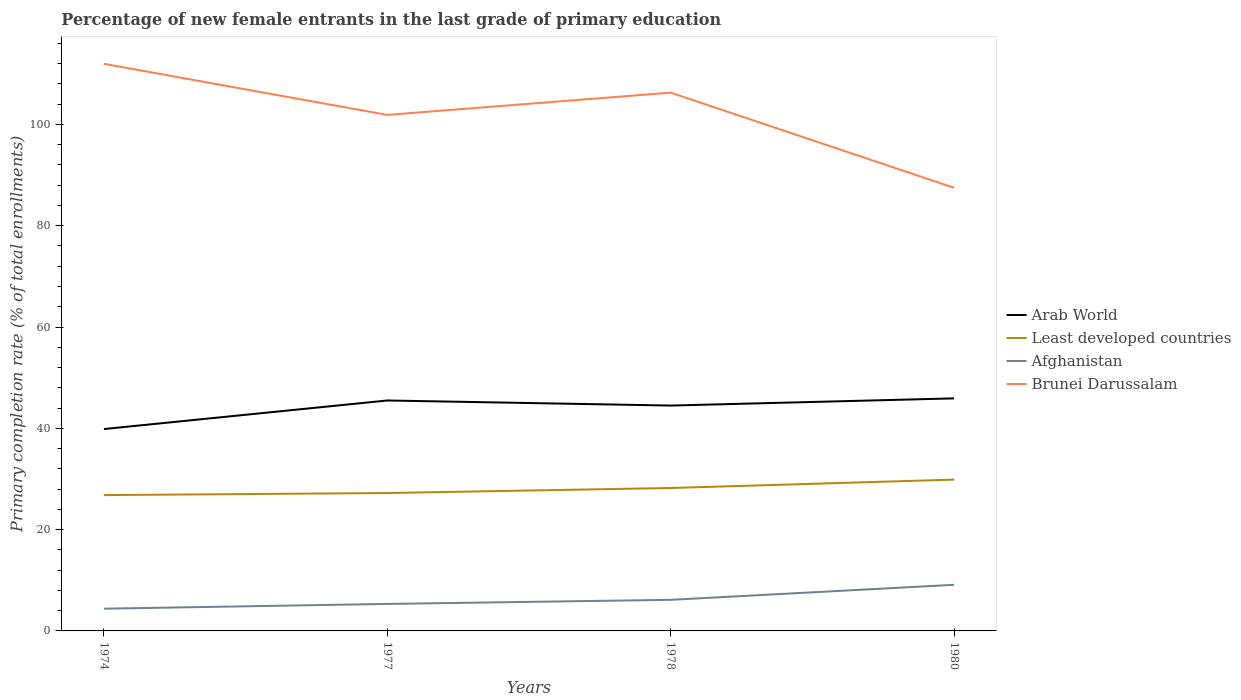Across all years, what is the maximum percentage of new female entrants in Brunei Darussalam?
Your answer should be very brief. 87.49. In which year was the percentage of new female entrants in Least developed countries maximum?
Make the answer very short. 1974. What is the total percentage of new female entrants in Arab World in the graph?
Provide a short and direct response. 1. What is the difference between the highest and the second highest percentage of new female entrants in Afghanistan?
Provide a succinct answer. 4.72. How many years are there in the graph?
Offer a very short reply. 4. What is the difference between two consecutive major ticks on the Y-axis?
Offer a terse response. 20. Are the values on the major ticks of Y-axis written in scientific E-notation?
Your response must be concise. No. What is the title of the graph?
Ensure brevity in your answer.  Percentage of new female entrants in the last grade of primary education. What is the label or title of the X-axis?
Provide a short and direct response. Years. What is the label or title of the Y-axis?
Provide a succinct answer. Primary completion rate (% of total enrollments). What is the Primary completion rate (% of total enrollments) of Arab World in 1974?
Your response must be concise. 39.86. What is the Primary completion rate (% of total enrollments) of Least developed countries in 1974?
Offer a terse response. 26.82. What is the Primary completion rate (% of total enrollments) of Afghanistan in 1974?
Make the answer very short. 4.39. What is the Primary completion rate (% of total enrollments) of Brunei Darussalam in 1974?
Ensure brevity in your answer.  111.97. What is the Primary completion rate (% of total enrollments) of Arab World in 1977?
Offer a very short reply. 45.5. What is the Primary completion rate (% of total enrollments) in Least developed countries in 1977?
Provide a short and direct response. 27.22. What is the Primary completion rate (% of total enrollments) of Afghanistan in 1977?
Ensure brevity in your answer.  5.33. What is the Primary completion rate (% of total enrollments) in Brunei Darussalam in 1977?
Make the answer very short. 101.88. What is the Primary completion rate (% of total enrollments) in Arab World in 1978?
Keep it short and to the point. 44.5. What is the Primary completion rate (% of total enrollments) of Least developed countries in 1978?
Your answer should be compact. 28.22. What is the Primary completion rate (% of total enrollments) of Afghanistan in 1978?
Make the answer very short. 6.14. What is the Primary completion rate (% of total enrollments) of Brunei Darussalam in 1978?
Give a very brief answer. 106.28. What is the Primary completion rate (% of total enrollments) of Arab World in 1980?
Offer a very short reply. 45.91. What is the Primary completion rate (% of total enrollments) of Least developed countries in 1980?
Offer a terse response. 29.87. What is the Primary completion rate (% of total enrollments) of Afghanistan in 1980?
Make the answer very short. 9.11. What is the Primary completion rate (% of total enrollments) in Brunei Darussalam in 1980?
Provide a succinct answer. 87.49. Across all years, what is the maximum Primary completion rate (% of total enrollments) in Arab World?
Offer a terse response. 45.91. Across all years, what is the maximum Primary completion rate (% of total enrollments) in Least developed countries?
Offer a terse response. 29.87. Across all years, what is the maximum Primary completion rate (% of total enrollments) in Afghanistan?
Make the answer very short. 9.11. Across all years, what is the maximum Primary completion rate (% of total enrollments) in Brunei Darussalam?
Your response must be concise. 111.97. Across all years, what is the minimum Primary completion rate (% of total enrollments) of Arab World?
Offer a terse response. 39.86. Across all years, what is the minimum Primary completion rate (% of total enrollments) in Least developed countries?
Provide a succinct answer. 26.82. Across all years, what is the minimum Primary completion rate (% of total enrollments) of Afghanistan?
Give a very brief answer. 4.39. Across all years, what is the minimum Primary completion rate (% of total enrollments) in Brunei Darussalam?
Offer a terse response. 87.49. What is the total Primary completion rate (% of total enrollments) of Arab World in the graph?
Your answer should be very brief. 175.76. What is the total Primary completion rate (% of total enrollments) of Least developed countries in the graph?
Your answer should be very brief. 112.14. What is the total Primary completion rate (% of total enrollments) of Afghanistan in the graph?
Ensure brevity in your answer.  24.97. What is the total Primary completion rate (% of total enrollments) of Brunei Darussalam in the graph?
Make the answer very short. 407.62. What is the difference between the Primary completion rate (% of total enrollments) in Arab World in 1974 and that in 1977?
Provide a short and direct response. -5.64. What is the difference between the Primary completion rate (% of total enrollments) in Least developed countries in 1974 and that in 1977?
Your answer should be very brief. -0.41. What is the difference between the Primary completion rate (% of total enrollments) of Afghanistan in 1974 and that in 1977?
Ensure brevity in your answer.  -0.94. What is the difference between the Primary completion rate (% of total enrollments) of Brunei Darussalam in 1974 and that in 1977?
Offer a very short reply. 10.09. What is the difference between the Primary completion rate (% of total enrollments) of Arab World in 1974 and that in 1978?
Give a very brief answer. -4.64. What is the difference between the Primary completion rate (% of total enrollments) in Least developed countries in 1974 and that in 1978?
Make the answer very short. -1.4. What is the difference between the Primary completion rate (% of total enrollments) in Afghanistan in 1974 and that in 1978?
Provide a succinct answer. -1.75. What is the difference between the Primary completion rate (% of total enrollments) of Brunei Darussalam in 1974 and that in 1978?
Make the answer very short. 5.69. What is the difference between the Primary completion rate (% of total enrollments) in Arab World in 1974 and that in 1980?
Ensure brevity in your answer.  -6.06. What is the difference between the Primary completion rate (% of total enrollments) in Least developed countries in 1974 and that in 1980?
Keep it short and to the point. -3.06. What is the difference between the Primary completion rate (% of total enrollments) of Afghanistan in 1974 and that in 1980?
Your response must be concise. -4.72. What is the difference between the Primary completion rate (% of total enrollments) of Brunei Darussalam in 1974 and that in 1980?
Offer a terse response. 24.47. What is the difference between the Primary completion rate (% of total enrollments) in Least developed countries in 1977 and that in 1978?
Your answer should be compact. -0.99. What is the difference between the Primary completion rate (% of total enrollments) in Afghanistan in 1977 and that in 1978?
Give a very brief answer. -0.81. What is the difference between the Primary completion rate (% of total enrollments) in Brunei Darussalam in 1977 and that in 1978?
Your answer should be compact. -4.4. What is the difference between the Primary completion rate (% of total enrollments) in Arab World in 1977 and that in 1980?
Provide a short and direct response. -0.42. What is the difference between the Primary completion rate (% of total enrollments) of Least developed countries in 1977 and that in 1980?
Offer a very short reply. -2.65. What is the difference between the Primary completion rate (% of total enrollments) of Afghanistan in 1977 and that in 1980?
Your response must be concise. -3.77. What is the difference between the Primary completion rate (% of total enrollments) in Brunei Darussalam in 1977 and that in 1980?
Offer a terse response. 14.39. What is the difference between the Primary completion rate (% of total enrollments) in Arab World in 1978 and that in 1980?
Make the answer very short. -1.42. What is the difference between the Primary completion rate (% of total enrollments) of Least developed countries in 1978 and that in 1980?
Your answer should be very brief. -1.66. What is the difference between the Primary completion rate (% of total enrollments) in Afghanistan in 1978 and that in 1980?
Make the answer very short. -2.97. What is the difference between the Primary completion rate (% of total enrollments) in Brunei Darussalam in 1978 and that in 1980?
Offer a very short reply. 18.78. What is the difference between the Primary completion rate (% of total enrollments) in Arab World in 1974 and the Primary completion rate (% of total enrollments) in Least developed countries in 1977?
Your response must be concise. 12.63. What is the difference between the Primary completion rate (% of total enrollments) in Arab World in 1974 and the Primary completion rate (% of total enrollments) in Afghanistan in 1977?
Offer a terse response. 34.53. What is the difference between the Primary completion rate (% of total enrollments) of Arab World in 1974 and the Primary completion rate (% of total enrollments) of Brunei Darussalam in 1977?
Your answer should be very brief. -62.02. What is the difference between the Primary completion rate (% of total enrollments) in Least developed countries in 1974 and the Primary completion rate (% of total enrollments) in Afghanistan in 1977?
Your answer should be compact. 21.49. What is the difference between the Primary completion rate (% of total enrollments) of Least developed countries in 1974 and the Primary completion rate (% of total enrollments) of Brunei Darussalam in 1977?
Your response must be concise. -75.06. What is the difference between the Primary completion rate (% of total enrollments) in Afghanistan in 1974 and the Primary completion rate (% of total enrollments) in Brunei Darussalam in 1977?
Your answer should be very brief. -97.49. What is the difference between the Primary completion rate (% of total enrollments) of Arab World in 1974 and the Primary completion rate (% of total enrollments) of Least developed countries in 1978?
Make the answer very short. 11.64. What is the difference between the Primary completion rate (% of total enrollments) in Arab World in 1974 and the Primary completion rate (% of total enrollments) in Afghanistan in 1978?
Keep it short and to the point. 33.72. What is the difference between the Primary completion rate (% of total enrollments) of Arab World in 1974 and the Primary completion rate (% of total enrollments) of Brunei Darussalam in 1978?
Your response must be concise. -66.42. What is the difference between the Primary completion rate (% of total enrollments) of Least developed countries in 1974 and the Primary completion rate (% of total enrollments) of Afghanistan in 1978?
Make the answer very short. 20.68. What is the difference between the Primary completion rate (% of total enrollments) in Least developed countries in 1974 and the Primary completion rate (% of total enrollments) in Brunei Darussalam in 1978?
Offer a very short reply. -79.46. What is the difference between the Primary completion rate (% of total enrollments) of Afghanistan in 1974 and the Primary completion rate (% of total enrollments) of Brunei Darussalam in 1978?
Offer a very short reply. -101.89. What is the difference between the Primary completion rate (% of total enrollments) in Arab World in 1974 and the Primary completion rate (% of total enrollments) in Least developed countries in 1980?
Give a very brief answer. 9.98. What is the difference between the Primary completion rate (% of total enrollments) in Arab World in 1974 and the Primary completion rate (% of total enrollments) in Afghanistan in 1980?
Give a very brief answer. 30.75. What is the difference between the Primary completion rate (% of total enrollments) of Arab World in 1974 and the Primary completion rate (% of total enrollments) of Brunei Darussalam in 1980?
Your response must be concise. -47.64. What is the difference between the Primary completion rate (% of total enrollments) of Least developed countries in 1974 and the Primary completion rate (% of total enrollments) of Afghanistan in 1980?
Give a very brief answer. 17.71. What is the difference between the Primary completion rate (% of total enrollments) of Least developed countries in 1974 and the Primary completion rate (% of total enrollments) of Brunei Darussalam in 1980?
Offer a terse response. -60.68. What is the difference between the Primary completion rate (% of total enrollments) of Afghanistan in 1974 and the Primary completion rate (% of total enrollments) of Brunei Darussalam in 1980?
Keep it short and to the point. -83.1. What is the difference between the Primary completion rate (% of total enrollments) in Arab World in 1977 and the Primary completion rate (% of total enrollments) in Least developed countries in 1978?
Offer a very short reply. 17.28. What is the difference between the Primary completion rate (% of total enrollments) of Arab World in 1977 and the Primary completion rate (% of total enrollments) of Afghanistan in 1978?
Give a very brief answer. 39.36. What is the difference between the Primary completion rate (% of total enrollments) of Arab World in 1977 and the Primary completion rate (% of total enrollments) of Brunei Darussalam in 1978?
Offer a very short reply. -60.78. What is the difference between the Primary completion rate (% of total enrollments) of Least developed countries in 1977 and the Primary completion rate (% of total enrollments) of Afghanistan in 1978?
Your response must be concise. 21.09. What is the difference between the Primary completion rate (% of total enrollments) of Least developed countries in 1977 and the Primary completion rate (% of total enrollments) of Brunei Darussalam in 1978?
Ensure brevity in your answer.  -79.05. What is the difference between the Primary completion rate (% of total enrollments) in Afghanistan in 1977 and the Primary completion rate (% of total enrollments) in Brunei Darussalam in 1978?
Make the answer very short. -100.95. What is the difference between the Primary completion rate (% of total enrollments) in Arab World in 1977 and the Primary completion rate (% of total enrollments) in Least developed countries in 1980?
Keep it short and to the point. 15.62. What is the difference between the Primary completion rate (% of total enrollments) of Arab World in 1977 and the Primary completion rate (% of total enrollments) of Afghanistan in 1980?
Keep it short and to the point. 36.39. What is the difference between the Primary completion rate (% of total enrollments) in Arab World in 1977 and the Primary completion rate (% of total enrollments) in Brunei Darussalam in 1980?
Keep it short and to the point. -42. What is the difference between the Primary completion rate (% of total enrollments) of Least developed countries in 1977 and the Primary completion rate (% of total enrollments) of Afghanistan in 1980?
Give a very brief answer. 18.12. What is the difference between the Primary completion rate (% of total enrollments) of Least developed countries in 1977 and the Primary completion rate (% of total enrollments) of Brunei Darussalam in 1980?
Your answer should be very brief. -60.27. What is the difference between the Primary completion rate (% of total enrollments) in Afghanistan in 1977 and the Primary completion rate (% of total enrollments) in Brunei Darussalam in 1980?
Provide a succinct answer. -82.16. What is the difference between the Primary completion rate (% of total enrollments) in Arab World in 1978 and the Primary completion rate (% of total enrollments) in Least developed countries in 1980?
Offer a terse response. 14.62. What is the difference between the Primary completion rate (% of total enrollments) in Arab World in 1978 and the Primary completion rate (% of total enrollments) in Afghanistan in 1980?
Ensure brevity in your answer.  35.39. What is the difference between the Primary completion rate (% of total enrollments) in Arab World in 1978 and the Primary completion rate (% of total enrollments) in Brunei Darussalam in 1980?
Make the answer very short. -43. What is the difference between the Primary completion rate (% of total enrollments) in Least developed countries in 1978 and the Primary completion rate (% of total enrollments) in Afghanistan in 1980?
Keep it short and to the point. 19.11. What is the difference between the Primary completion rate (% of total enrollments) of Least developed countries in 1978 and the Primary completion rate (% of total enrollments) of Brunei Darussalam in 1980?
Offer a very short reply. -59.28. What is the difference between the Primary completion rate (% of total enrollments) in Afghanistan in 1978 and the Primary completion rate (% of total enrollments) in Brunei Darussalam in 1980?
Make the answer very short. -81.36. What is the average Primary completion rate (% of total enrollments) of Arab World per year?
Keep it short and to the point. 43.94. What is the average Primary completion rate (% of total enrollments) of Least developed countries per year?
Offer a terse response. 28.03. What is the average Primary completion rate (% of total enrollments) in Afghanistan per year?
Your response must be concise. 6.24. What is the average Primary completion rate (% of total enrollments) of Brunei Darussalam per year?
Provide a short and direct response. 101.91. In the year 1974, what is the difference between the Primary completion rate (% of total enrollments) of Arab World and Primary completion rate (% of total enrollments) of Least developed countries?
Provide a short and direct response. 13.04. In the year 1974, what is the difference between the Primary completion rate (% of total enrollments) of Arab World and Primary completion rate (% of total enrollments) of Afghanistan?
Provide a succinct answer. 35.47. In the year 1974, what is the difference between the Primary completion rate (% of total enrollments) of Arab World and Primary completion rate (% of total enrollments) of Brunei Darussalam?
Your answer should be very brief. -72.11. In the year 1974, what is the difference between the Primary completion rate (% of total enrollments) of Least developed countries and Primary completion rate (% of total enrollments) of Afghanistan?
Provide a short and direct response. 22.43. In the year 1974, what is the difference between the Primary completion rate (% of total enrollments) of Least developed countries and Primary completion rate (% of total enrollments) of Brunei Darussalam?
Offer a terse response. -85.15. In the year 1974, what is the difference between the Primary completion rate (% of total enrollments) in Afghanistan and Primary completion rate (% of total enrollments) in Brunei Darussalam?
Provide a short and direct response. -107.58. In the year 1977, what is the difference between the Primary completion rate (% of total enrollments) of Arab World and Primary completion rate (% of total enrollments) of Least developed countries?
Your response must be concise. 18.27. In the year 1977, what is the difference between the Primary completion rate (% of total enrollments) in Arab World and Primary completion rate (% of total enrollments) in Afghanistan?
Make the answer very short. 40.16. In the year 1977, what is the difference between the Primary completion rate (% of total enrollments) in Arab World and Primary completion rate (% of total enrollments) in Brunei Darussalam?
Provide a short and direct response. -56.39. In the year 1977, what is the difference between the Primary completion rate (% of total enrollments) in Least developed countries and Primary completion rate (% of total enrollments) in Afghanistan?
Provide a succinct answer. 21.89. In the year 1977, what is the difference between the Primary completion rate (% of total enrollments) in Least developed countries and Primary completion rate (% of total enrollments) in Brunei Darussalam?
Offer a terse response. -74.66. In the year 1977, what is the difference between the Primary completion rate (% of total enrollments) of Afghanistan and Primary completion rate (% of total enrollments) of Brunei Darussalam?
Your response must be concise. -96.55. In the year 1978, what is the difference between the Primary completion rate (% of total enrollments) in Arab World and Primary completion rate (% of total enrollments) in Least developed countries?
Provide a short and direct response. 16.28. In the year 1978, what is the difference between the Primary completion rate (% of total enrollments) in Arab World and Primary completion rate (% of total enrollments) in Afghanistan?
Offer a very short reply. 38.36. In the year 1978, what is the difference between the Primary completion rate (% of total enrollments) in Arab World and Primary completion rate (% of total enrollments) in Brunei Darussalam?
Provide a succinct answer. -61.78. In the year 1978, what is the difference between the Primary completion rate (% of total enrollments) of Least developed countries and Primary completion rate (% of total enrollments) of Afghanistan?
Your answer should be very brief. 22.08. In the year 1978, what is the difference between the Primary completion rate (% of total enrollments) in Least developed countries and Primary completion rate (% of total enrollments) in Brunei Darussalam?
Your answer should be compact. -78.06. In the year 1978, what is the difference between the Primary completion rate (% of total enrollments) in Afghanistan and Primary completion rate (% of total enrollments) in Brunei Darussalam?
Offer a very short reply. -100.14. In the year 1980, what is the difference between the Primary completion rate (% of total enrollments) of Arab World and Primary completion rate (% of total enrollments) of Least developed countries?
Offer a terse response. 16.04. In the year 1980, what is the difference between the Primary completion rate (% of total enrollments) in Arab World and Primary completion rate (% of total enrollments) in Afghanistan?
Offer a very short reply. 36.81. In the year 1980, what is the difference between the Primary completion rate (% of total enrollments) in Arab World and Primary completion rate (% of total enrollments) in Brunei Darussalam?
Provide a short and direct response. -41.58. In the year 1980, what is the difference between the Primary completion rate (% of total enrollments) of Least developed countries and Primary completion rate (% of total enrollments) of Afghanistan?
Your answer should be compact. 20.77. In the year 1980, what is the difference between the Primary completion rate (% of total enrollments) of Least developed countries and Primary completion rate (% of total enrollments) of Brunei Darussalam?
Make the answer very short. -57.62. In the year 1980, what is the difference between the Primary completion rate (% of total enrollments) in Afghanistan and Primary completion rate (% of total enrollments) in Brunei Darussalam?
Ensure brevity in your answer.  -78.39. What is the ratio of the Primary completion rate (% of total enrollments) of Arab World in 1974 to that in 1977?
Keep it short and to the point. 0.88. What is the ratio of the Primary completion rate (% of total enrollments) of Least developed countries in 1974 to that in 1977?
Provide a short and direct response. 0.99. What is the ratio of the Primary completion rate (% of total enrollments) of Afghanistan in 1974 to that in 1977?
Give a very brief answer. 0.82. What is the ratio of the Primary completion rate (% of total enrollments) of Brunei Darussalam in 1974 to that in 1977?
Offer a terse response. 1.1. What is the ratio of the Primary completion rate (% of total enrollments) in Arab World in 1974 to that in 1978?
Your response must be concise. 0.9. What is the ratio of the Primary completion rate (% of total enrollments) in Least developed countries in 1974 to that in 1978?
Give a very brief answer. 0.95. What is the ratio of the Primary completion rate (% of total enrollments) of Afghanistan in 1974 to that in 1978?
Offer a terse response. 0.72. What is the ratio of the Primary completion rate (% of total enrollments) of Brunei Darussalam in 1974 to that in 1978?
Your answer should be very brief. 1.05. What is the ratio of the Primary completion rate (% of total enrollments) of Arab World in 1974 to that in 1980?
Provide a succinct answer. 0.87. What is the ratio of the Primary completion rate (% of total enrollments) of Least developed countries in 1974 to that in 1980?
Offer a terse response. 0.9. What is the ratio of the Primary completion rate (% of total enrollments) of Afghanistan in 1974 to that in 1980?
Your answer should be very brief. 0.48. What is the ratio of the Primary completion rate (% of total enrollments) in Brunei Darussalam in 1974 to that in 1980?
Provide a short and direct response. 1.28. What is the ratio of the Primary completion rate (% of total enrollments) in Arab World in 1977 to that in 1978?
Provide a short and direct response. 1.02. What is the ratio of the Primary completion rate (% of total enrollments) in Least developed countries in 1977 to that in 1978?
Provide a succinct answer. 0.96. What is the ratio of the Primary completion rate (% of total enrollments) of Afghanistan in 1977 to that in 1978?
Keep it short and to the point. 0.87. What is the ratio of the Primary completion rate (% of total enrollments) of Brunei Darussalam in 1977 to that in 1978?
Offer a very short reply. 0.96. What is the ratio of the Primary completion rate (% of total enrollments) in Arab World in 1977 to that in 1980?
Your answer should be very brief. 0.99. What is the ratio of the Primary completion rate (% of total enrollments) in Least developed countries in 1977 to that in 1980?
Your response must be concise. 0.91. What is the ratio of the Primary completion rate (% of total enrollments) in Afghanistan in 1977 to that in 1980?
Keep it short and to the point. 0.59. What is the ratio of the Primary completion rate (% of total enrollments) in Brunei Darussalam in 1977 to that in 1980?
Provide a short and direct response. 1.16. What is the ratio of the Primary completion rate (% of total enrollments) of Arab World in 1978 to that in 1980?
Your response must be concise. 0.97. What is the ratio of the Primary completion rate (% of total enrollments) in Least developed countries in 1978 to that in 1980?
Offer a terse response. 0.94. What is the ratio of the Primary completion rate (% of total enrollments) in Afghanistan in 1978 to that in 1980?
Your answer should be very brief. 0.67. What is the ratio of the Primary completion rate (% of total enrollments) of Brunei Darussalam in 1978 to that in 1980?
Your answer should be very brief. 1.21. What is the difference between the highest and the second highest Primary completion rate (% of total enrollments) of Arab World?
Offer a terse response. 0.42. What is the difference between the highest and the second highest Primary completion rate (% of total enrollments) of Least developed countries?
Offer a terse response. 1.66. What is the difference between the highest and the second highest Primary completion rate (% of total enrollments) in Afghanistan?
Provide a succinct answer. 2.97. What is the difference between the highest and the second highest Primary completion rate (% of total enrollments) in Brunei Darussalam?
Provide a succinct answer. 5.69. What is the difference between the highest and the lowest Primary completion rate (% of total enrollments) of Arab World?
Provide a short and direct response. 6.06. What is the difference between the highest and the lowest Primary completion rate (% of total enrollments) in Least developed countries?
Make the answer very short. 3.06. What is the difference between the highest and the lowest Primary completion rate (% of total enrollments) in Afghanistan?
Provide a succinct answer. 4.72. What is the difference between the highest and the lowest Primary completion rate (% of total enrollments) of Brunei Darussalam?
Provide a succinct answer. 24.47. 